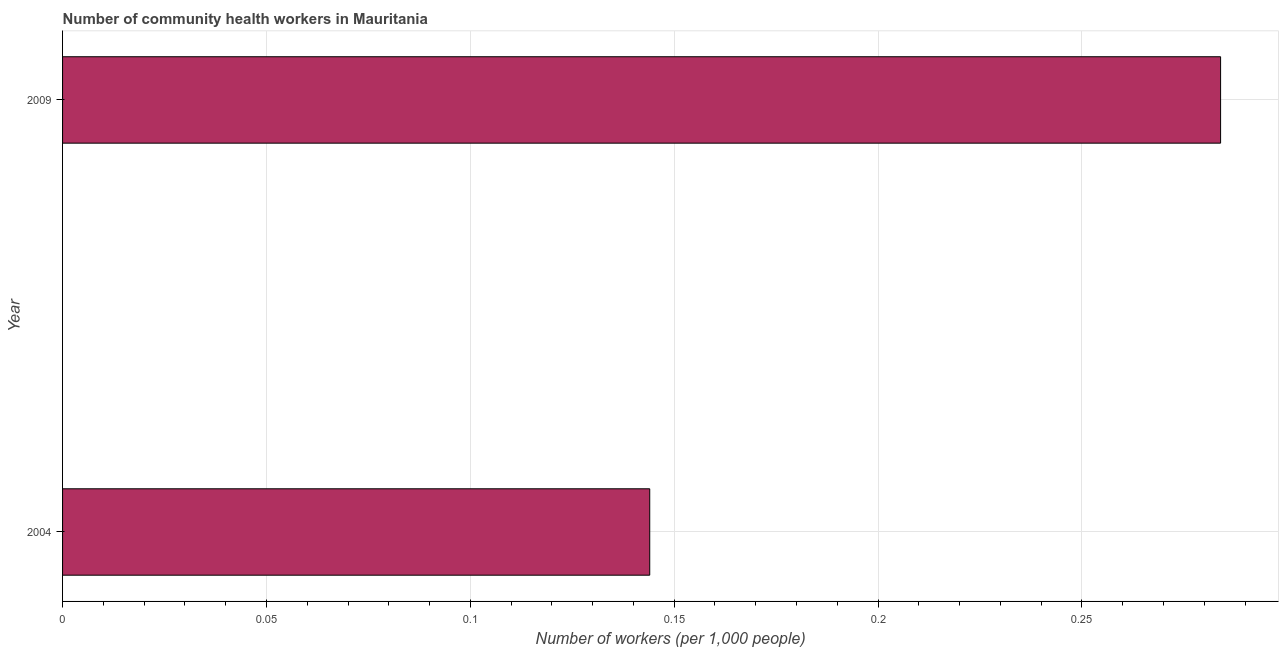Does the graph contain grids?
Offer a terse response. Yes. What is the title of the graph?
Ensure brevity in your answer.  Number of community health workers in Mauritania. What is the label or title of the X-axis?
Keep it short and to the point. Number of workers (per 1,0 people). What is the number of community health workers in 2009?
Give a very brief answer. 0.28. Across all years, what is the maximum number of community health workers?
Your answer should be compact. 0.28. Across all years, what is the minimum number of community health workers?
Make the answer very short. 0.14. What is the sum of the number of community health workers?
Your response must be concise. 0.43. What is the difference between the number of community health workers in 2004 and 2009?
Make the answer very short. -0.14. What is the average number of community health workers per year?
Provide a short and direct response. 0.21. What is the median number of community health workers?
Give a very brief answer. 0.21. What is the ratio of the number of community health workers in 2004 to that in 2009?
Offer a very short reply. 0.51. Is the number of community health workers in 2004 less than that in 2009?
Your response must be concise. Yes. In how many years, is the number of community health workers greater than the average number of community health workers taken over all years?
Make the answer very short. 1. How many bars are there?
Provide a succinct answer. 2. Are all the bars in the graph horizontal?
Make the answer very short. Yes. What is the Number of workers (per 1,000 people) in 2004?
Your answer should be very brief. 0.14. What is the Number of workers (per 1,000 people) in 2009?
Make the answer very short. 0.28. What is the difference between the Number of workers (per 1,000 people) in 2004 and 2009?
Offer a terse response. -0.14. What is the ratio of the Number of workers (per 1,000 people) in 2004 to that in 2009?
Offer a terse response. 0.51. 